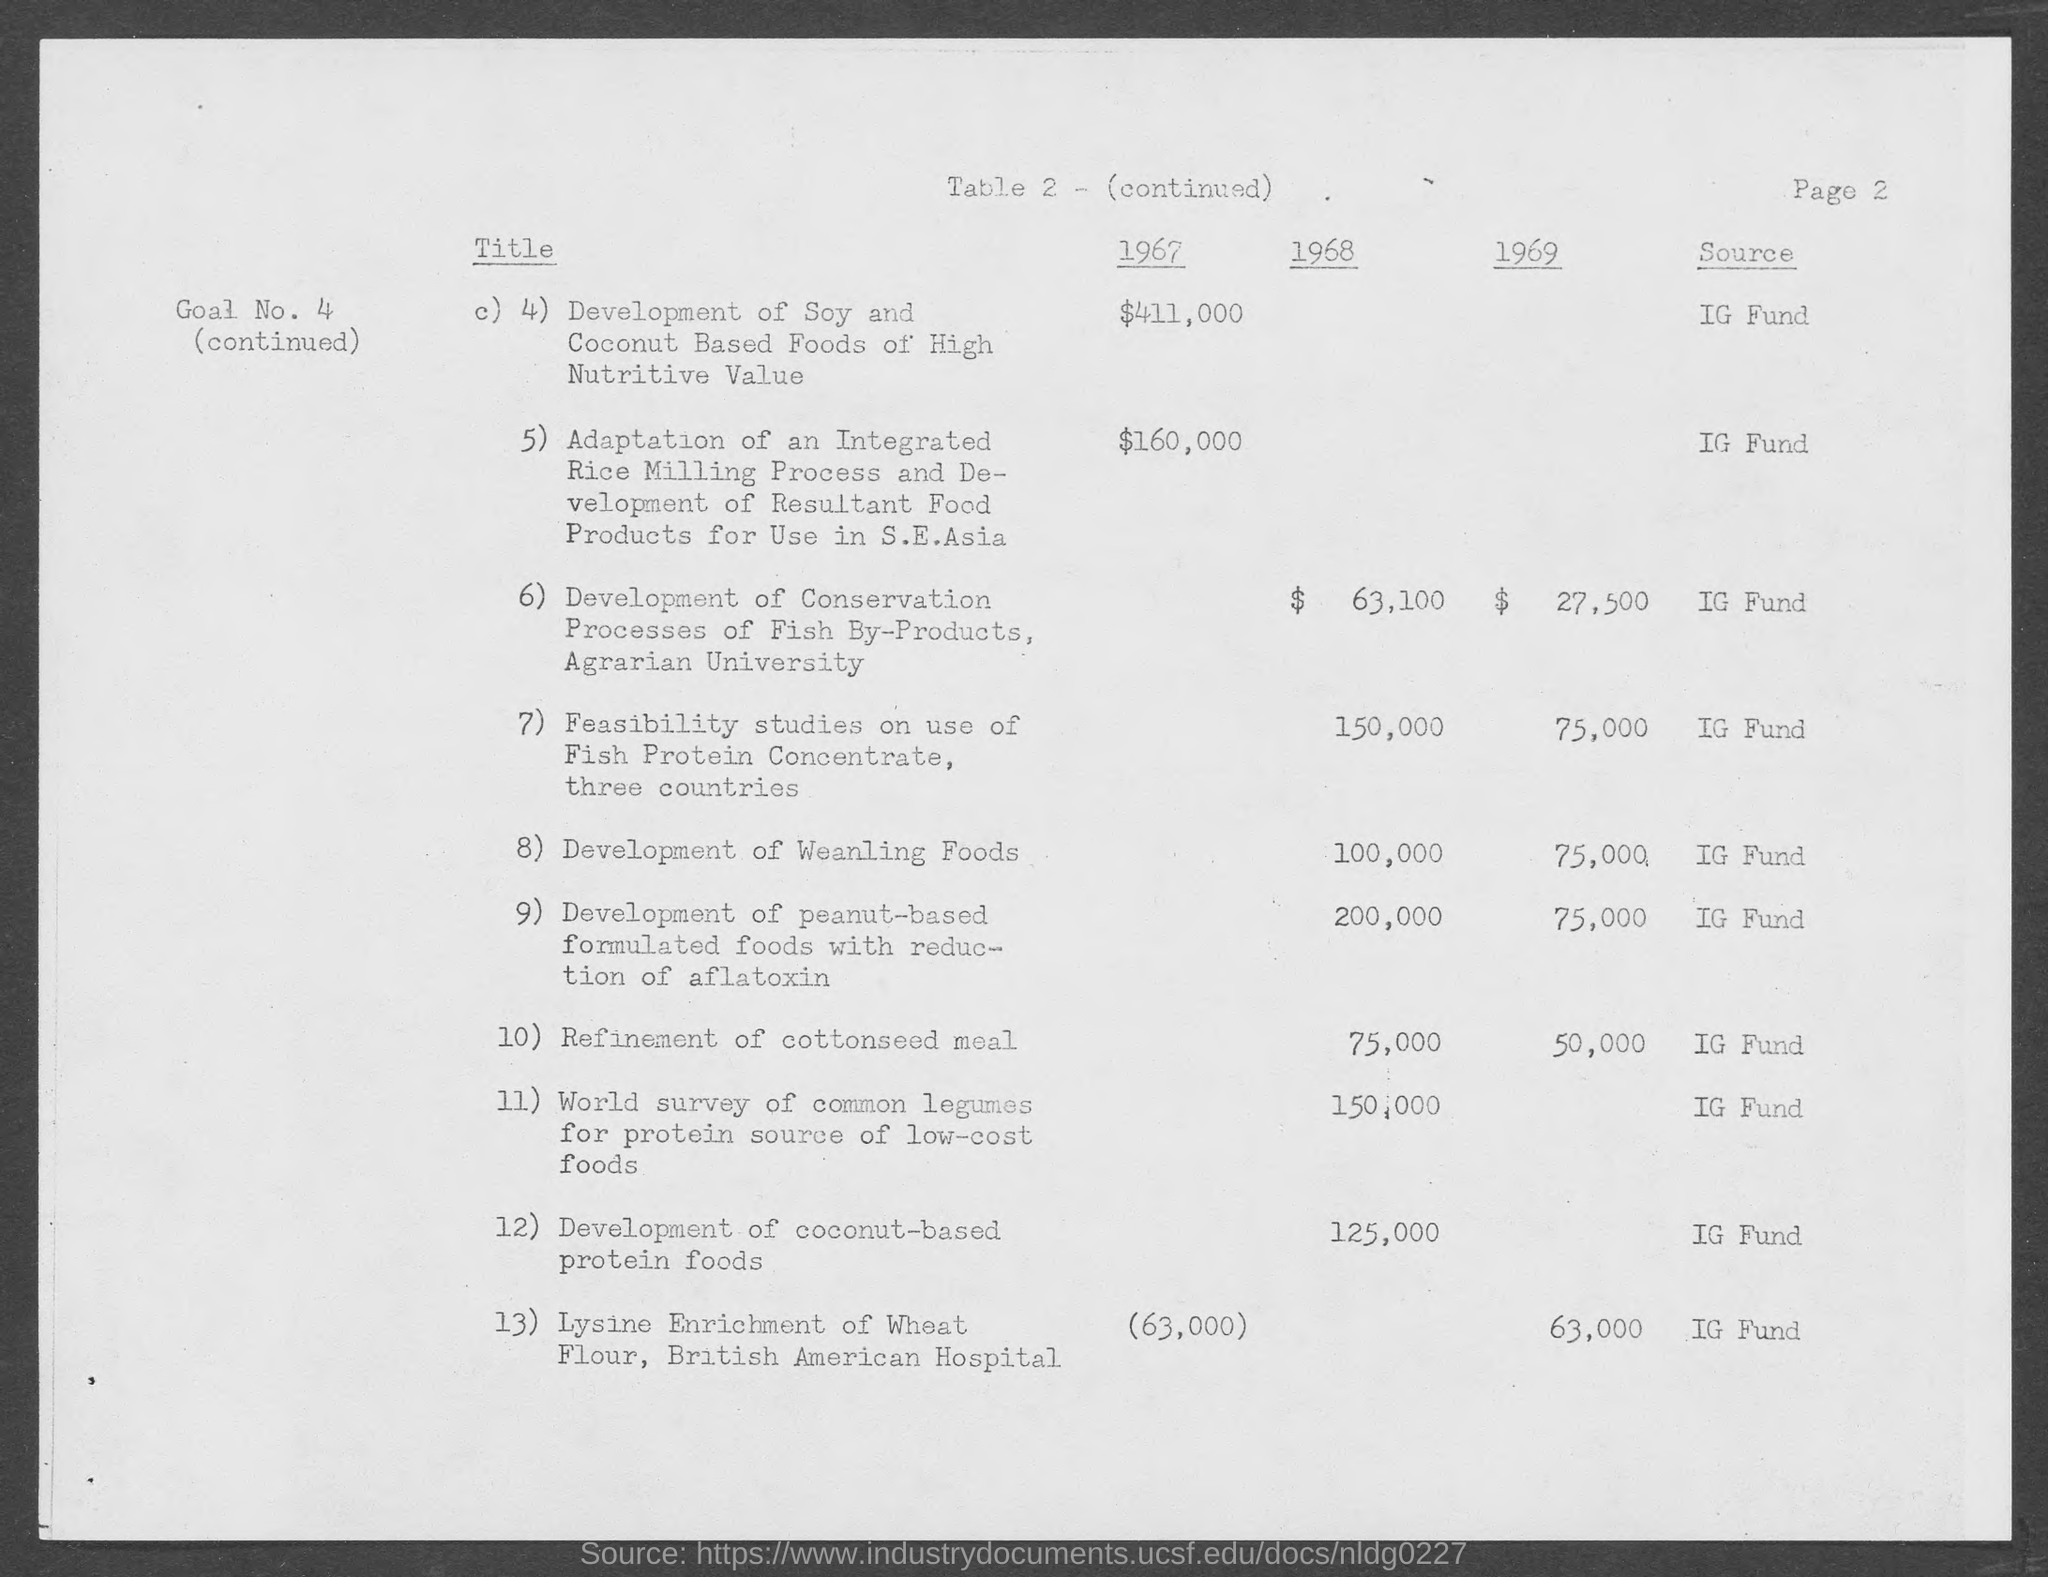What is the source fund for the amount mentioned?
Provide a succinct answer. IG Fund. Feasibility studies use of fish protein concentrate is for how many countries?
Provide a short and direct response. Three countries. 